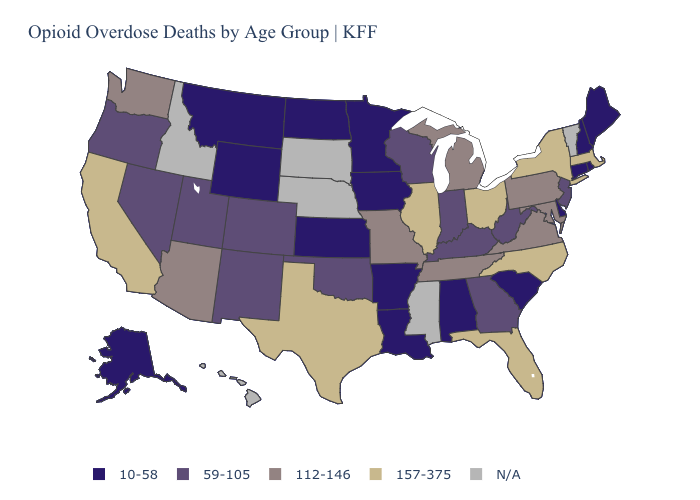Name the states that have a value in the range 112-146?
Quick response, please. Arizona, Maryland, Michigan, Missouri, Pennsylvania, Tennessee, Virginia, Washington. Name the states that have a value in the range N/A?
Give a very brief answer. Hawaii, Idaho, Mississippi, Nebraska, South Dakota, Vermont. What is the value of Alabama?
Give a very brief answer. 10-58. Name the states that have a value in the range 10-58?
Write a very short answer. Alabama, Alaska, Arkansas, Connecticut, Delaware, Iowa, Kansas, Louisiana, Maine, Minnesota, Montana, New Hampshire, North Dakota, Rhode Island, South Carolina, Wyoming. What is the value of Texas?
Answer briefly. 157-375. Does Georgia have the highest value in the South?
Concise answer only. No. What is the highest value in the South ?
Answer briefly. 157-375. Name the states that have a value in the range 112-146?
Quick response, please. Arizona, Maryland, Michigan, Missouri, Pennsylvania, Tennessee, Virginia, Washington. How many symbols are there in the legend?
Concise answer only. 5. Among the states that border Alabama , which have the highest value?
Short answer required. Florida. What is the highest value in the West ?
Short answer required. 157-375. What is the value of Idaho?
Give a very brief answer. N/A. Does Montana have the lowest value in the West?
Be succinct. Yes. What is the lowest value in the USA?
Be succinct. 10-58. Name the states that have a value in the range 112-146?
Answer briefly. Arizona, Maryland, Michigan, Missouri, Pennsylvania, Tennessee, Virginia, Washington. 